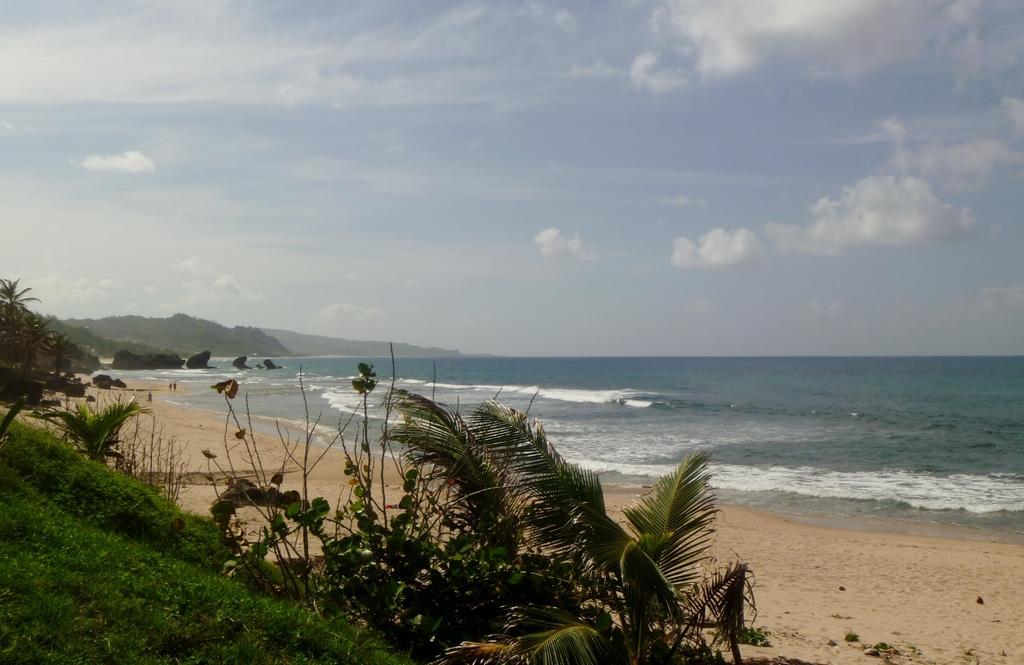Could you give a brief overview of what you see in this image? At the bottom, we see the trees and the sand. On the left side, we see the trees and grass. In this picture, we see water and this water might be in the sea. There are hills in the background. At the top, we see the sky and the clouds. This picture might be clicked at the seashore. 